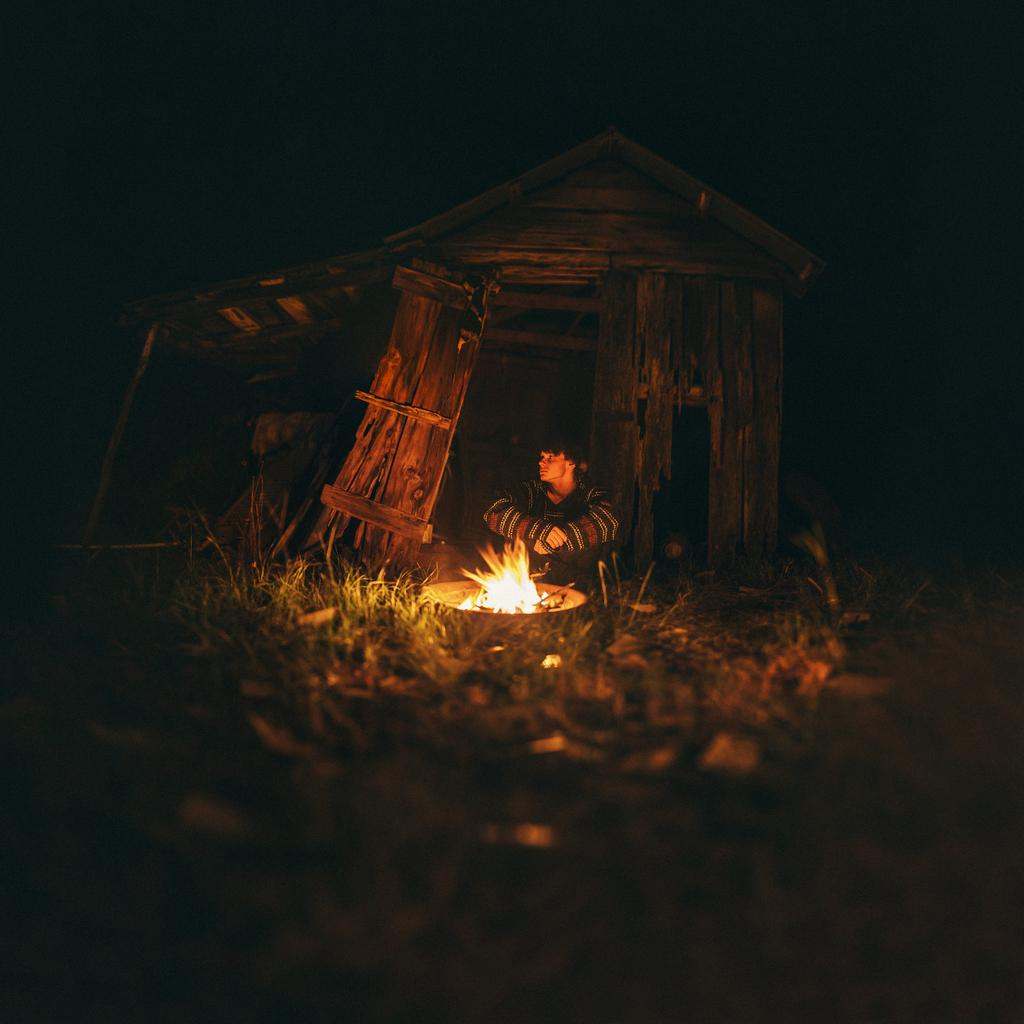What is the person in the image doing? There is a person sitting on the ground in the image. What can be seen in the image besides the person? There is fire in the image. What type of structure is visible in the background? There is a hut in the background of the image. How would you describe the lighting in the image? The background of the image has a dark view. What type of music is the band playing in the image? There is no band present in the image, so it is not possible to determine what type of music they might be playing. 